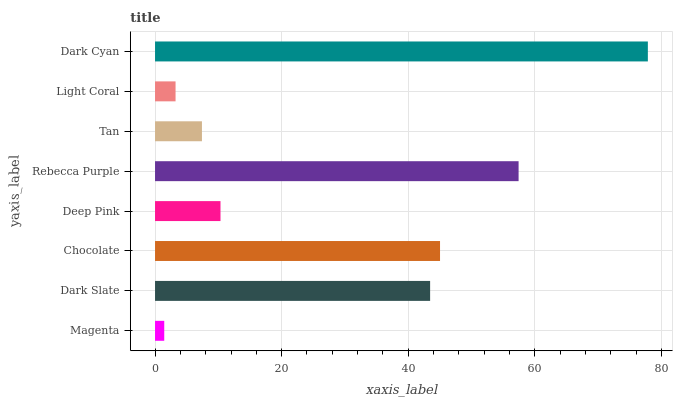Is Magenta the minimum?
Answer yes or no. Yes. Is Dark Cyan the maximum?
Answer yes or no. Yes. Is Dark Slate the minimum?
Answer yes or no. No. Is Dark Slate the maximum?
Answer yes or no. No. Is Dark Slate greater than Magenta?
Answer yes or no. Yes. Is Magenta less than Dark Slate?
Answer yes or no. Yes. Is Magenta greater than Dark Slate?
Answer yes or no. No. Is Dark Slate less than Magenta?
Answer yes or no. No. Is Dark Slate the high median?
Answer yes or no. Yes. Is Deep Pink the low median?
Answer yes or no. Yes. Is Chocolate the high median?
Answer yes or no. No. Is Tan the low median?
Answer yes or no. No. 